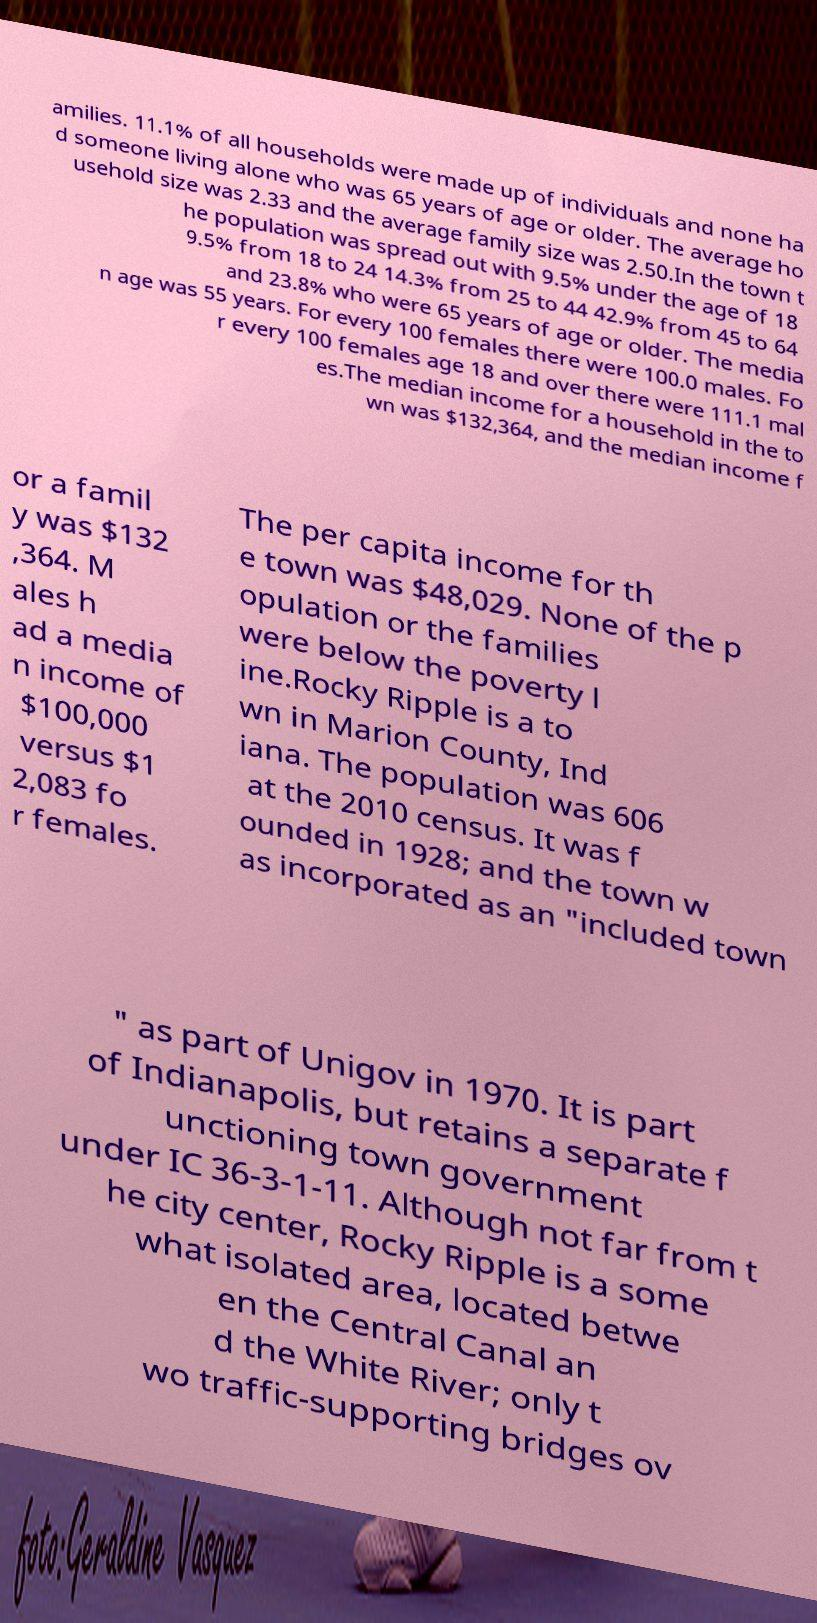Could you assist in decoding the text presented in this image and type it out clearly? amilies. 11.1% of all households were made up of individuals and none ha d someone living alone who was 65 years of age or older. The average ho usehold size was 2.33 and the average family size was 2.50.In the town t he population was spread out with 9.5% under the age of 18 9.5% from 18 to 24 14.3% from 25 to 44 42.9% from 45 to 64 and 23.8% who were 65 years of age or older. The media n age was 55 years. For every 100 females there were 100.0 males. Fo r every 100 females age 18 and over there were 111.1 mal es.The median income for a household in the to wn was $132,364, and the median income f or a famil y was $132 ,364. M ales h ad a media n income of $100,000 versus $1 2,083 fo r females. The per capita income for th e town was $48,029. None of the p opulation or the families were below the poverty l ine.Rocky Ripple is a to wn in Marion County, Ind iana. The population was 606 at the 2010 census. It was f ounded in 1928; and the town w as incorporated as an "included town " as part of Unigov in 1970. It is part of Indianapolis, but retains a separate f unctioning town government under IC 36-3-1-11. Although not far from t he city center, Rocky Ripple is a some what isolated area, located betwe en the Central Canal an d the White River; only t wo traffic-supporting bridges ov 